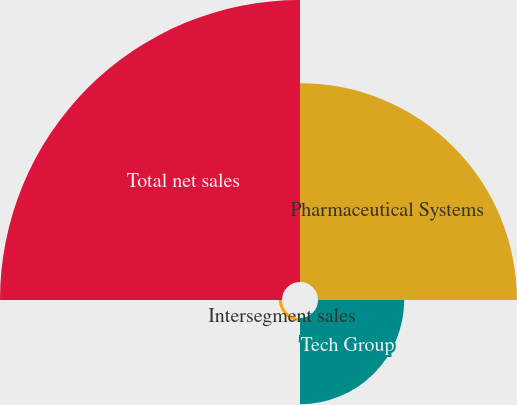Convert chart. <chart><loc_0><loc_0><loc_500><loc_500><pie_chart><fcel>Pharmaceutical Systems<fcel>Tech Group<fcel>Intersegment sales<fcel>Total net sales<nl><fcel>34.88%<fcel>15.12%<fcel>0.54%<fcel>49.46%<nl></chart> 